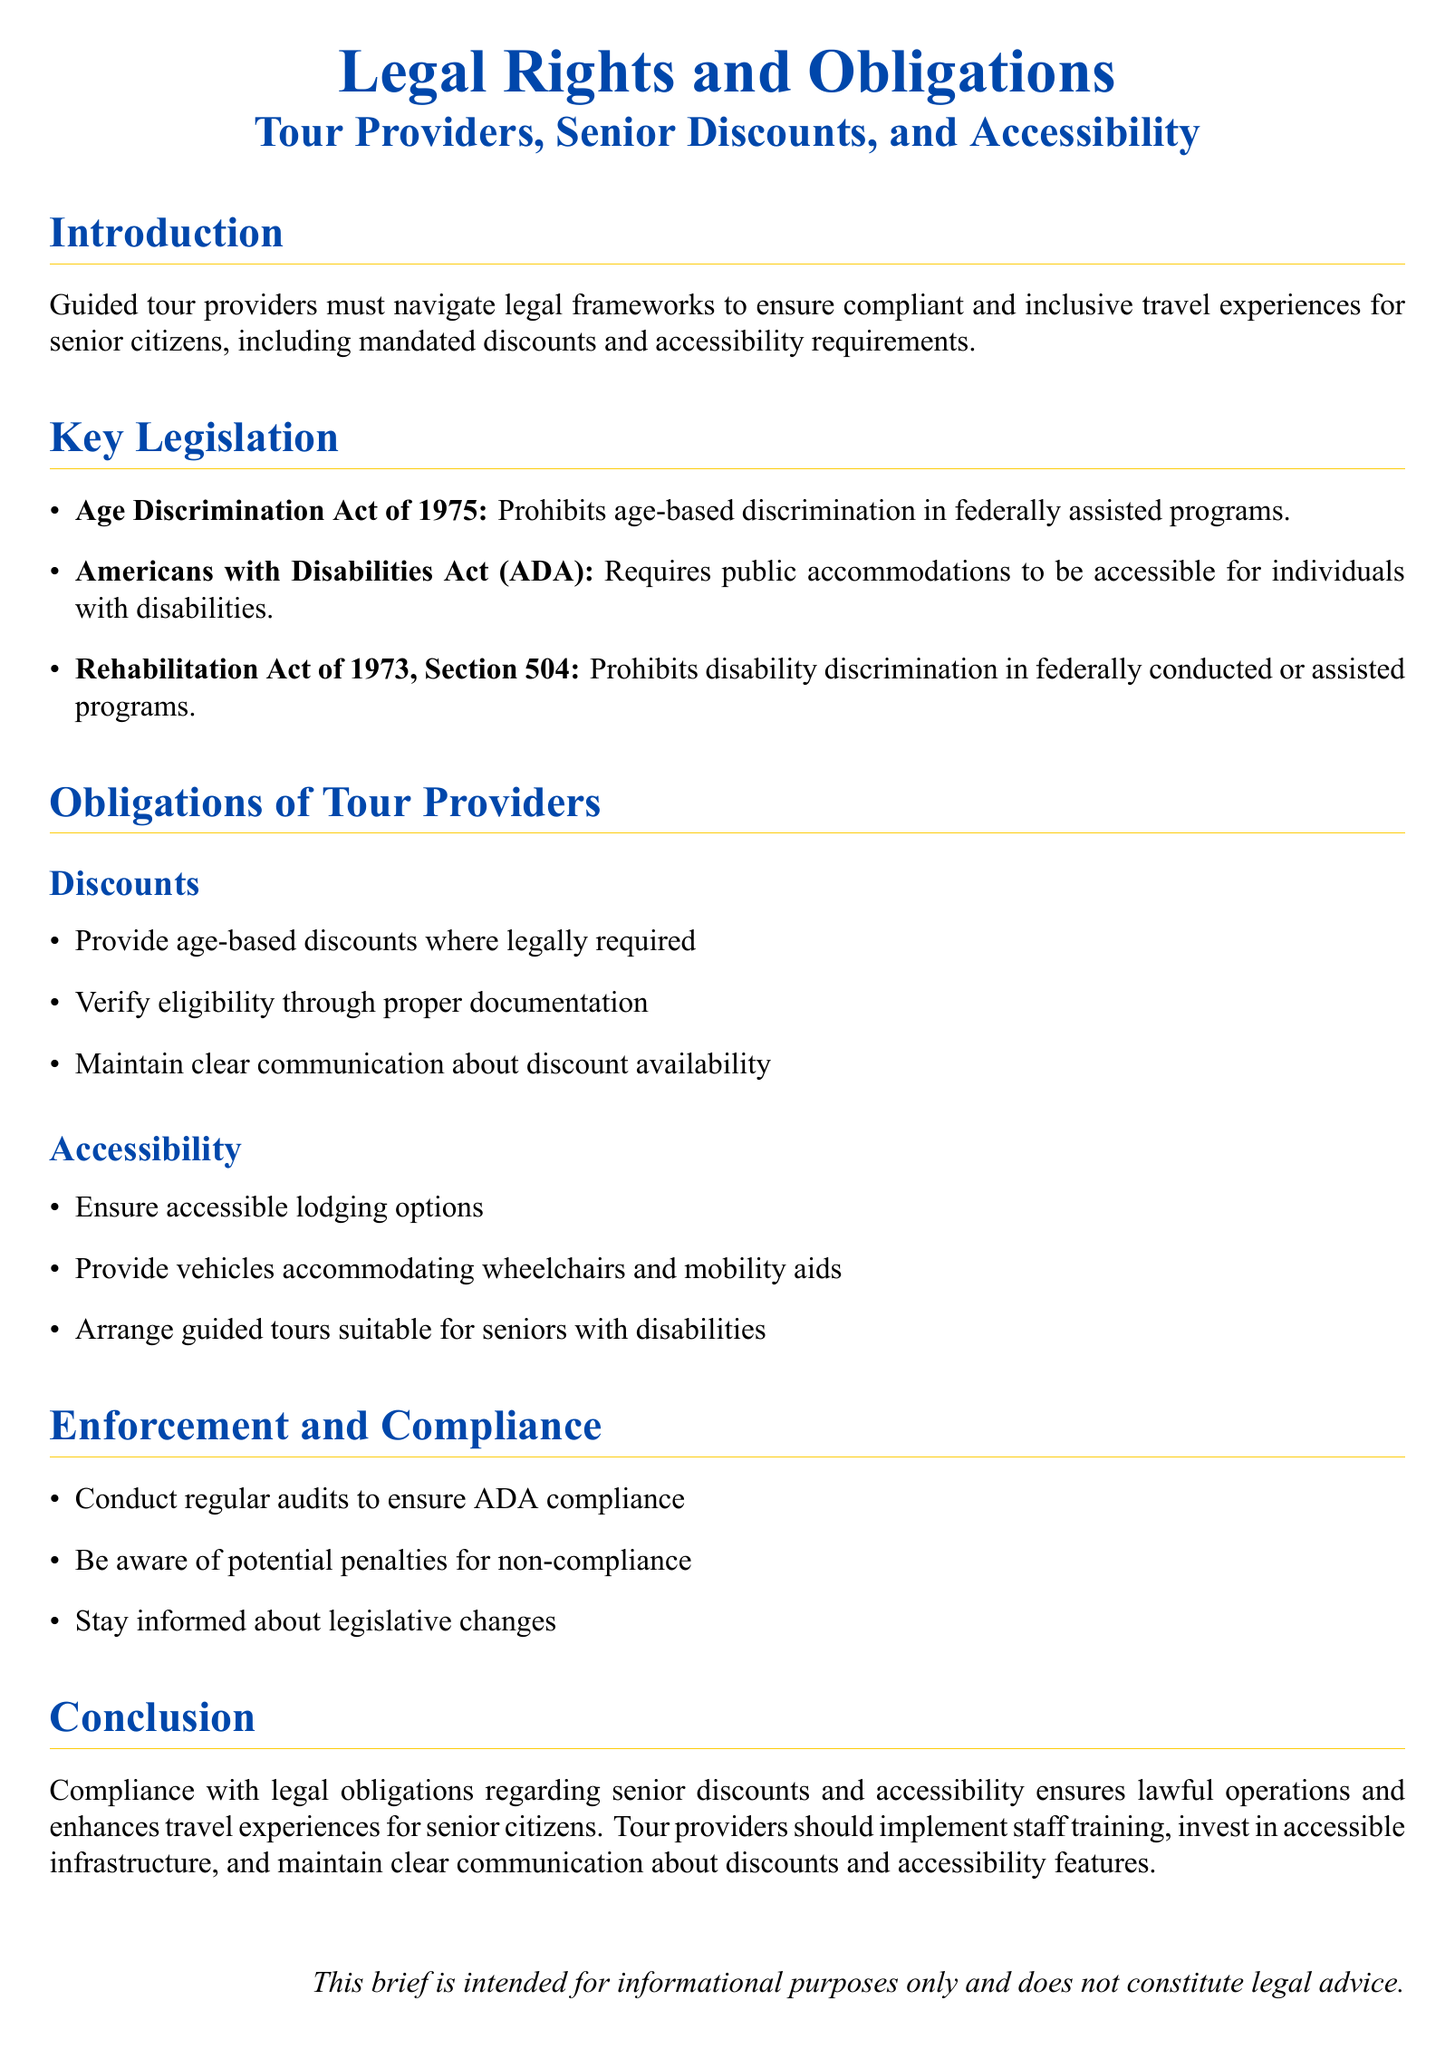What is the title of the document? The title is indicated in the header section of the document.
Answer: Legal Rights and Obligations What year was the Age Discrimination Act enacted? The specific year of enactment is mentioned in the document.
Answer: 1975 What does ADA stand for? ADA is an abbreviation used in the document referring to a specific act.
Answer: Americans with Disabilities Act What are tour providers required to ensure regarding lodging? The document outlines specific obligations concerning accommodations for senior citizens.
Answer: Accessible lodging options How often should tour providers conduct audits for compliance? The document implies a frequency related to maintaining legal compliance.
Answer: Regularly What is one potential consequence of non-compliance mentioned? The document refers to a specific outcome of failing to meet legal standards.
Answer: Penalties What type of training should providers implement? The conclusion section mentions an important aspect of ongoing staff development.
Answer: Staff training Who is this brief intended for? The document specifies the target audience for the information provided.
Answer: Informational purposes only 